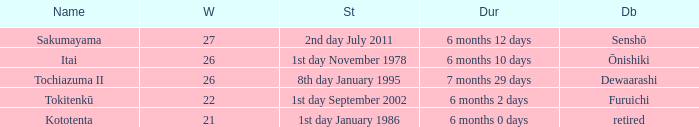How many wins, on average, were defeated by furuichi? 22.0. 